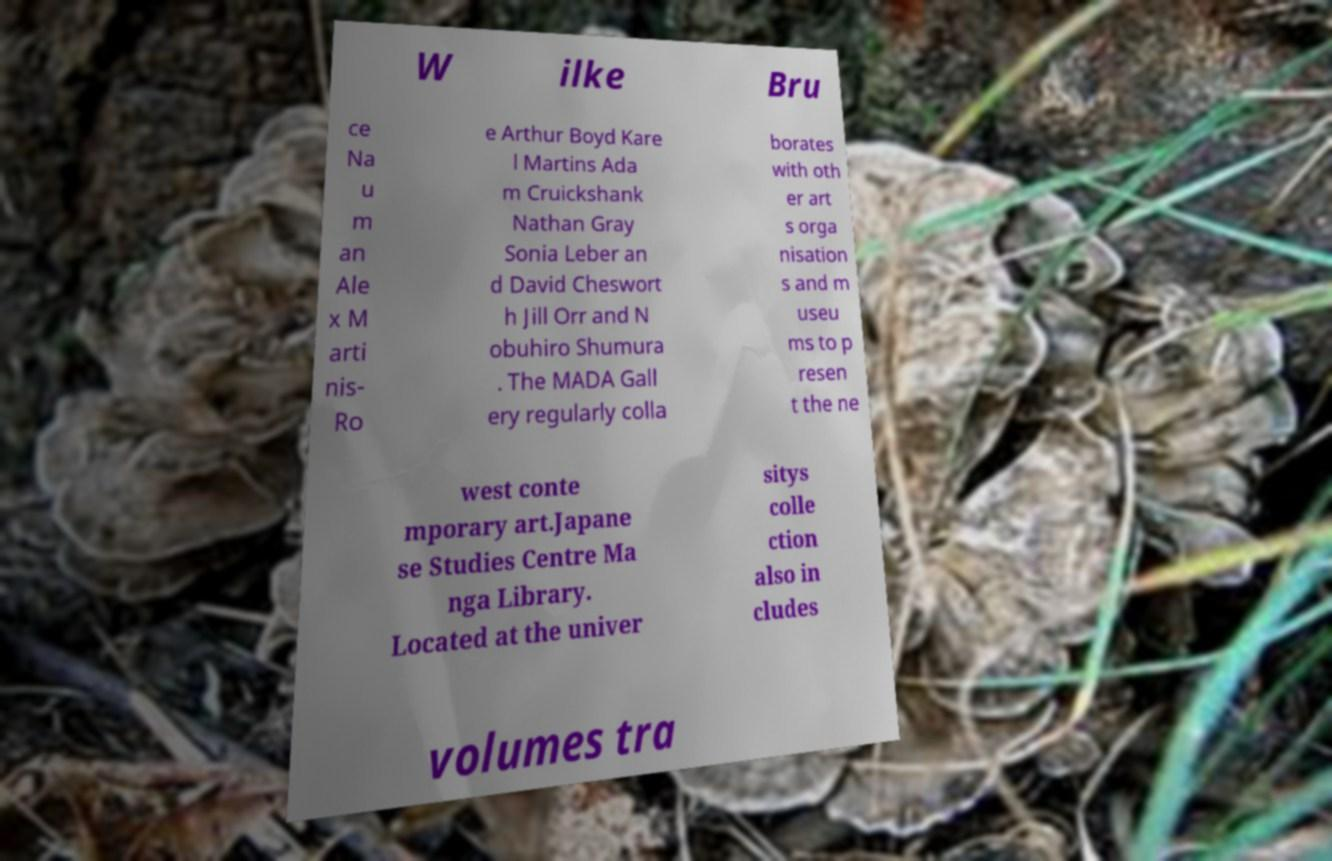Please identify and transcribe the text found in this image. W ilke Bru ce Na u m an Ale x M arti nis- Ro e Arthur Boyd Kare l Martins Ada m Cruickshank Nathan Gray Sonia Leber an d David Cheswort h Jill Orr and N obuhiro Shumura . The MADA Gall ery regularly colla borates with oth er art s orga nisation s and m useu ms to p resen t the ne west conte mporary art.Japane se Studies Centre Ma nga Library. Located at the univer sitys colle ction also in cludes volumes tra 